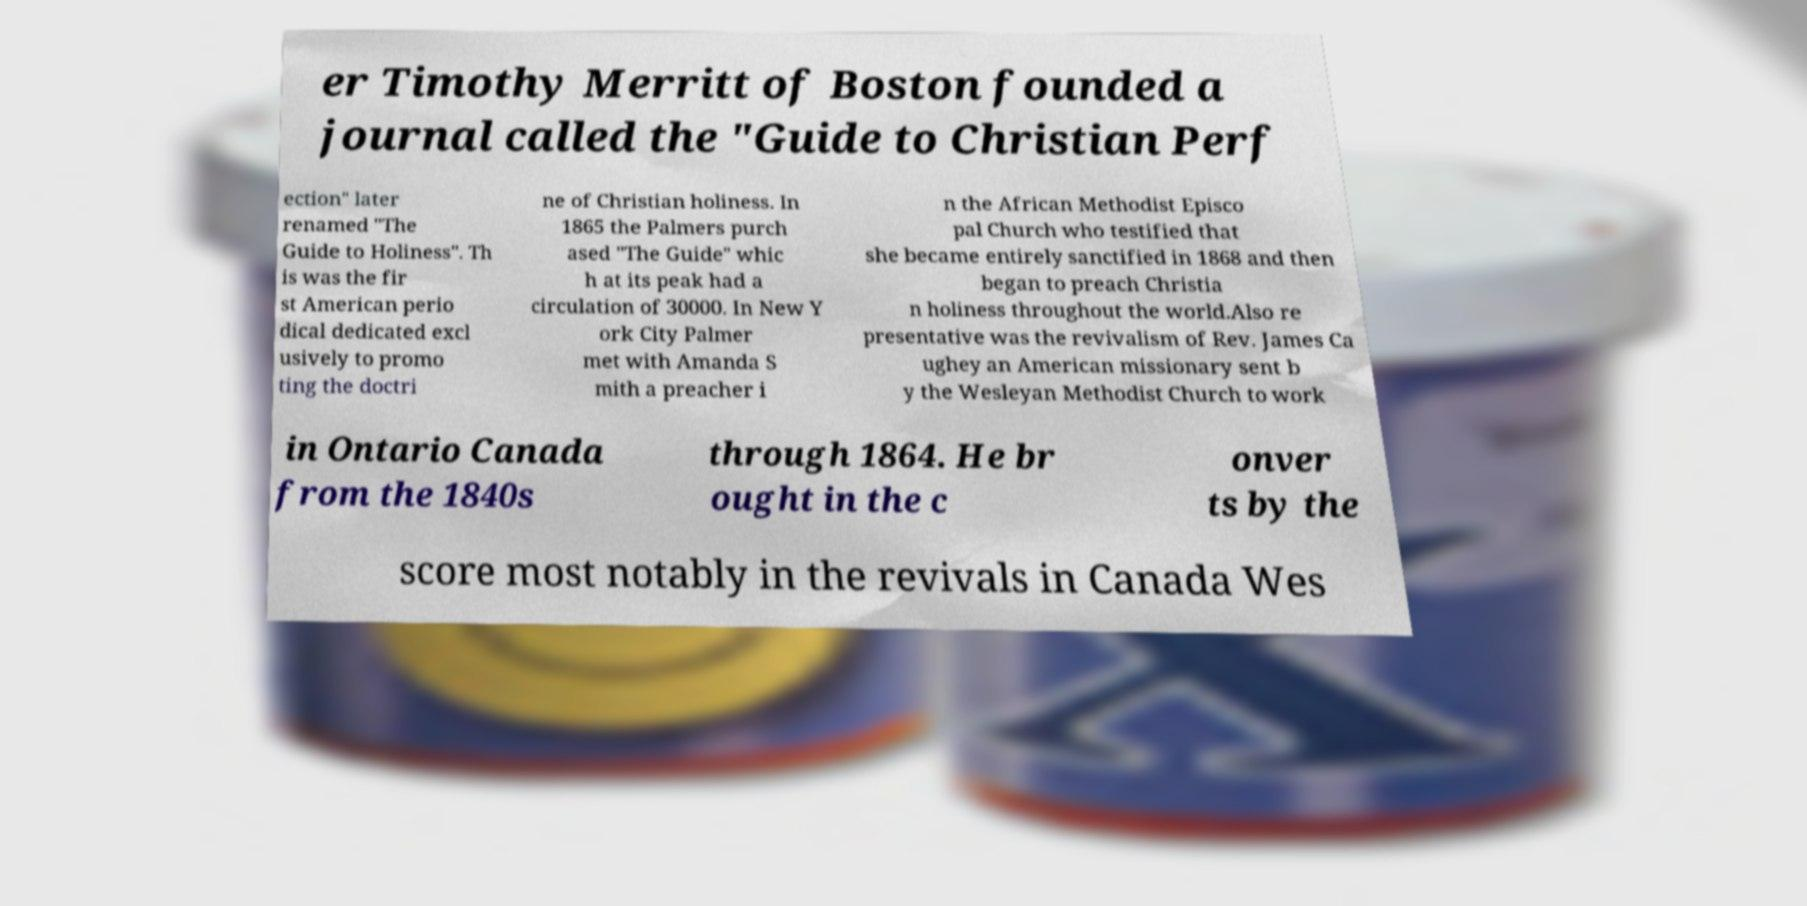I need the written content from this picture converted into text. Can you do that? er Timothy Merritt of Boston founded a journal called the "Guide to Christian Perf ection" later renamed "The Guide to Holiness". Th is was the fir st American perio dical dedicated excl usively to promo ting the doctri ne of Christian holiness. In 1865 the Palmers purch ased "The Guide" whic h at its peak had a circulation of 30000. In New Y ork City Palmer met with Amanda S mith a preacher i n the African Methodist Episco pal Church who testified that she became entirely sanctified in 1868 and then began to preach Christia n holiness throughout the world.Also re presentative was the revivalism of Rev. James Ca ughey an American missionary sent b y the Wesleyan Methodist Church to work in Ontario Canada from the 1840s through 1864. He br ought in the c onver ts by the score most notably in the revivals in Canada Wes 